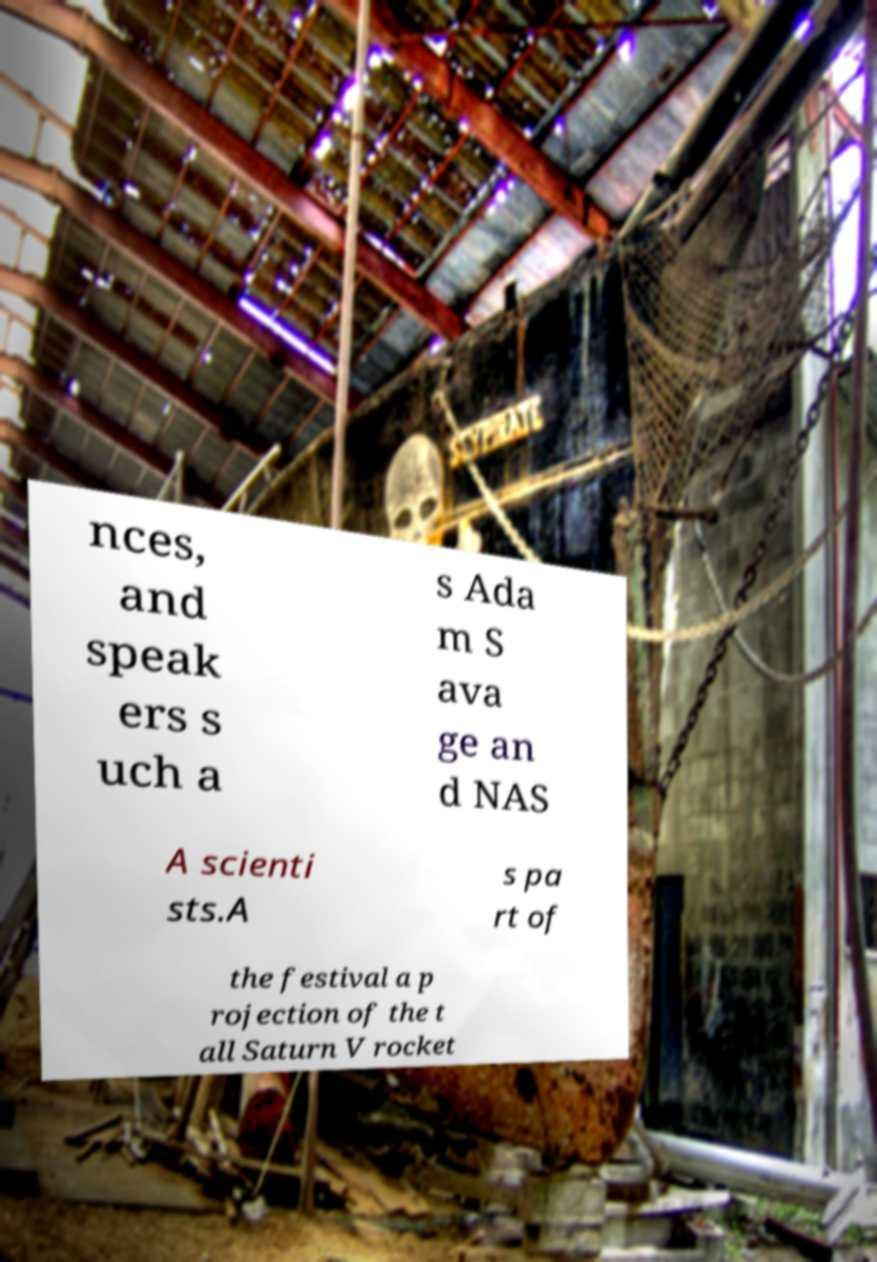Can you accurately transcribe the text from the provided image for me? nces, and speak ers s uch a s Ada m S ava ge an d NAS A scienti sts.A s pa rt of the festival a p rojection of the t all Saturn V rocket 